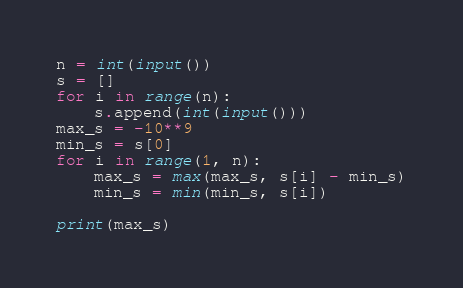<code> <loc_0><loc_0><loc_500><loc_500><_Python_>n = int(input())
s = []
for i in range(n):
    s.append(int(input()))
max_s = -10**9
min_s = s[0]
for i in range(1, n):
    max_s = max(max_s, s[i] - min_s)
    min_s = min(min_s, s[i])

print(max_s)
</code> 